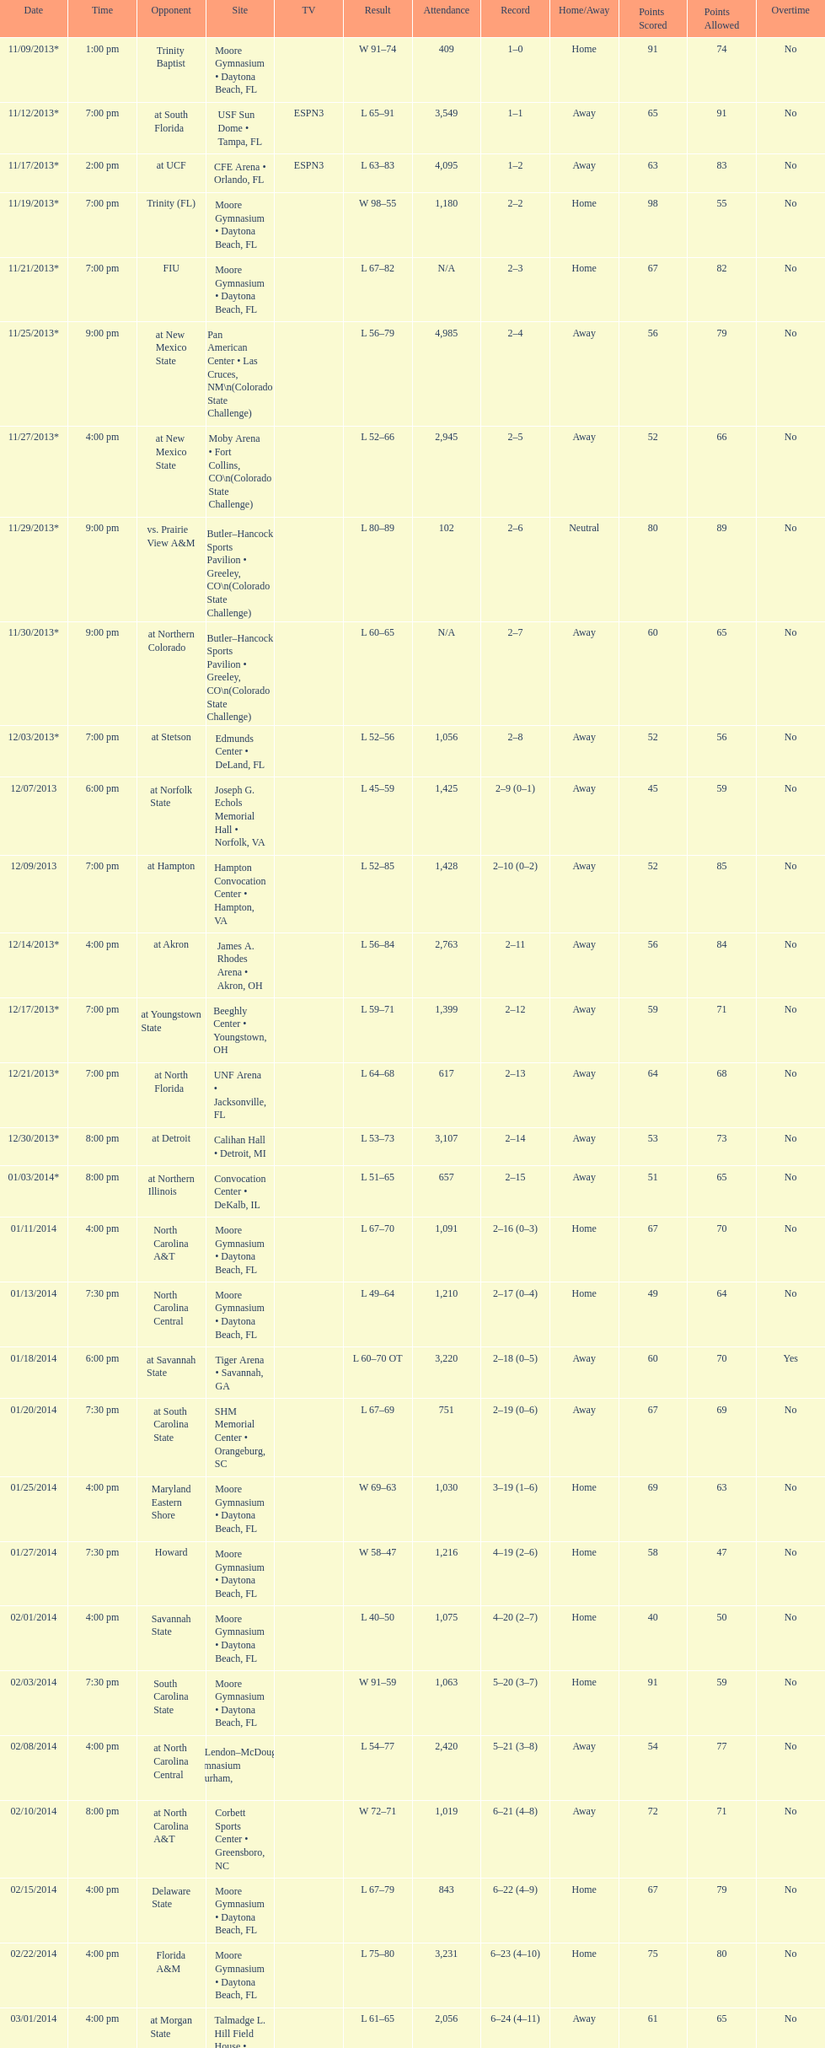Parse the full table. {'header': ['Date', 'Time', 'Opponent', 'Site', 'TV', 'Result', 'Attendance', 'Record', 'Home/Away', 'Points Scored', 'Points Allowed', 'Overtime'], 'rows': [['11/09/2013*', '1:00 pm', 'Trinity Baptist', 'Moore Gymnasium • Daytona Beach, FL', '', 'W\xa091–74', '409', '1–0', 'Home', '91', '74', 'No'], ['11/12/2013*', '7:00 pm', 'at\xa0South Florida', 'USF Sun Dome • Tampa, FL', 'ESPN3', 'L\xa065–91', '3,549', '1–1', 'Away', '65', '91', 'No'], ['11/17/2013*', '2:00 pm', 'at\xa0UCF', 'CFE Arena • Orlando, FL', 'ESPN3', 'L\xa063–83', '4,095', '1–2', 'Away', '63', '83', 'No'], ['11/19/2013*', '7:00 pm', 'Trinity (FL)', 'Moore Gymnasium • Daytona Beach, FL', '', 'W\xa098–55', '1,180', '2–2', 'Home', '98', '55', 'No'], ['11/21/2013*', '7:00 pm', 'FIU', 'Moore Gymnasium • Daytona Beach, FL', '', 'L\xa067–82', 'N/A', '2–3', 'Home', '67', '82', 'No'], ['11/25/2013*', '9:00 pm', 'at\xa0New Mexico State', 'Pan American Center • Las Cruces, NM\\n(Colorado State Challenge)', '', 'L\xa056–79', '4,985', '2–4', 'Away', '56', '79', 'No'], ['11/27/2013*', '4:00 pm', 'at\xa0New Mexico State', 'Moby Arena • Fort Collins, CO\\n(Colorado State Challenge)', '', 'L\xa052–66', '2,945', '2–5', 'Away', '52', '66', 'No'], ['11/29/2013*', '9:00 pm', 'vs.\xa0Prairie View A&M', 'Butler–Hancock Sports Pavilion • Greeley, CO\\n(Colorado State Challenge)', '', 'L\xa080–89', '102', '2–6', 'Neutral', '80', '89', 'No'], ['11/30/2013*', '9:00 pm', 'at\xa0Northern Colorado', 'Butler–Hancock Sports Pavilion • Greeley, CO\\n(Colorado State Challenge)', '', 'L\xa060–65', 'N/A', '2–7', 'Away', '60', '65', 'No'], ['12/03/2013*', '7:00 pm', 'at\xa0Stetson', 'Edmunds Center • DeLand, FL', '', 'L\xa052–56', '1,056', '2–8', 'Away', '52', '56', 'No'], ['12/07/2013', '6:00 pm', 'at\xa0Norfolk State', 'Joseph G. Echols Memorial Hall • Norfolk, VA', '', 'L\xa045–59', '1,425', '2–9 (0–1)', 'Away', '45', '59', 'No'], ['12/09/2013', '7:00 pm', 'at\xa0Hampton', 'Hampton Convocation Center • Hampton, VA', '', 'L\xa052–85', '1,428', '2–10 (0–2)', 'Away', '52', '85', 'No'], ['12/14/2013*', '4:00 pm', 'at\xa0Akron', 'James A. Rhodes Arena • Akron, OH', '', 'L\xa056–84', '2,763', '2–11', 'Away', '56', '84', 'No'], ['12/17/2013*', '7:00 pm', 'at\xa0Youngstown State', 'Beeghly Center • Youngstown, OH', '', 'L\xa059–71', '1,399', '2–12', 'Away', '59', '71', 'No'], ['12/21/2013*', '7:00 pm', 'at\xa0North Florida', 'UNF Arena • Jacksonville, FL', '', 'L\xa064–68', '617', '2–13', 'Away', '64', '68', 'No'], ['12/30/2013*', '8:00 pm', 'at\xa0Detroit', 'Calihan Hall • Detroit, MI', '', 'L\xa053–73', '3,107', '2–14', 'Away', '53', '73', 'No'], ['01/03/2014*', '8:00 pm', 'at\xa0Northern Illinois', 'Convocation Center • DeKalb, IL', '', 'L\xa051–65', '657', '2–15', 'Away', '51', '65', 'No'], ['01/11/2014', '4:00 pm', 'North Carolina A&T', 'Moore Gymnasium • Daytona Beach, FL', '', 'L\xa067–70', '1,091', '2–16 (0–3)', 'Home', '67', '70', 'No'], ['01/13/2014', '7:30 pm', 'North Carolina Central', 'Moore Gymnasium • Daytona Beach, FL', '', 'L\xa049–64', '1,210', '2–17 (0–4)', 'Home', '49', '64', 'No'], ['01/18/2014', '6:00 pm', 'at\xa0Savannah State', 'Tiger Arena • Savannah, GA', '', 'L\xa060–70\xa0OT', '3,220', '2–18 (0–5)', 'Away', '60', '70', 'Yes'], ['01/20/2014', '7:30 pm', 'at\xa0South Carolina State', 'SHM Memorial Center • Orangeburg, SC', '', 'L\xa067–69', '751', '2–19 (0–6)', 'Away', '67', '69', 'No'], ['01/25/2014', '4:00 pm', 'Maryland Eastern Shore', 'Moore Gymnasium • Daytona Beach, FL', '', 'W\xa069–63', '1,030', '3–19 (1–6)', 'Home', '69', '63', 'No'], ['01/27/2014', '7:30 pm', 'Howard', 'Moore Gymnasium • Daytona Beach, FL', '', 'W\xa058–47', '1,216', '4–19 (2–6)', 'Home', '58', '47', 'No'], ['02/01/2014', '4:00 pm', 'Savannah State', 'Moore Gymnasium • Daytona Beach, FL', '', 'L\xa040–50', '1,075', '4–20 (2–7)', 'Home', '40', '50', 'No'], ['02/03/2014', '7:30 pm', 'South Carolina State', 'Moore Gymnasium • Daytona Beach, FL', '', 'W\xa091–59', '1,063', '5–20 (3–7)', 'Home', '91', '59', 'No'], ['02/08/2014', '4:00 pm', 'at\xa0North Carolina Central', 'McLendon–McDougald Gymnasium • Durham, NC', '', 'L\xa054–77', '2,420', '5–21 (3–8)', 'Away', '54', '77', 'No'], ['02/10/2014', '8:00 pm', 'at\xa0North Carolina A&T', 'Corbett Sports Center • Greensboro, NC', '', 'W\xa072–71', '1,019', '6–21 (4–8)', 'Away', '72', '71', 'No'], ['02/15/2014', '4:00 pm', 'Delaware State', 'Moore Gymnasium • Daytona Beach, FL', '', 'L\xa067–79', '843', '6–22 (4–9)', 'Home', '67', '79', 'No'], ['02/22/2014', '4:00 pm', 'Florida A&M', 'Moore Gymnasium • Daytona Beach, FL', '', 'L\xa075–80', '3,231', '6–23 (4–10)', 'Home', '75', '80', 'No'], ['03/01/2014', '4:00 pm', 'at\xa0Morgan State', 'Talmadge L. Hill Field House • Baltimore, MD', '', 'L\xa061–65', '2,056', '6–24 (4–11)', 'Away', '61', '65', 'No'], ['03/06/2014', '7:30 pm', 'at\xa0Florida A&M', 'Teaching Gym • Tallahassee, FL', '', 'W\xa070–68', '2,376', '7–24 (5–11)', 'Away', '70', '68', 'No'], ['03/11/2014', '6:30 pm', 'vs.\xa0Coppin State', 'Norfolk Scope • Norfolk, VA\\n(First round)', '', 'L\xa068–75', '4,658', '7–25', 'Neutral', '68', '75', 'No']]} Which game was won by a bigger margin, against trinity (fl) or against trinity baptist? Trinity (FL). 